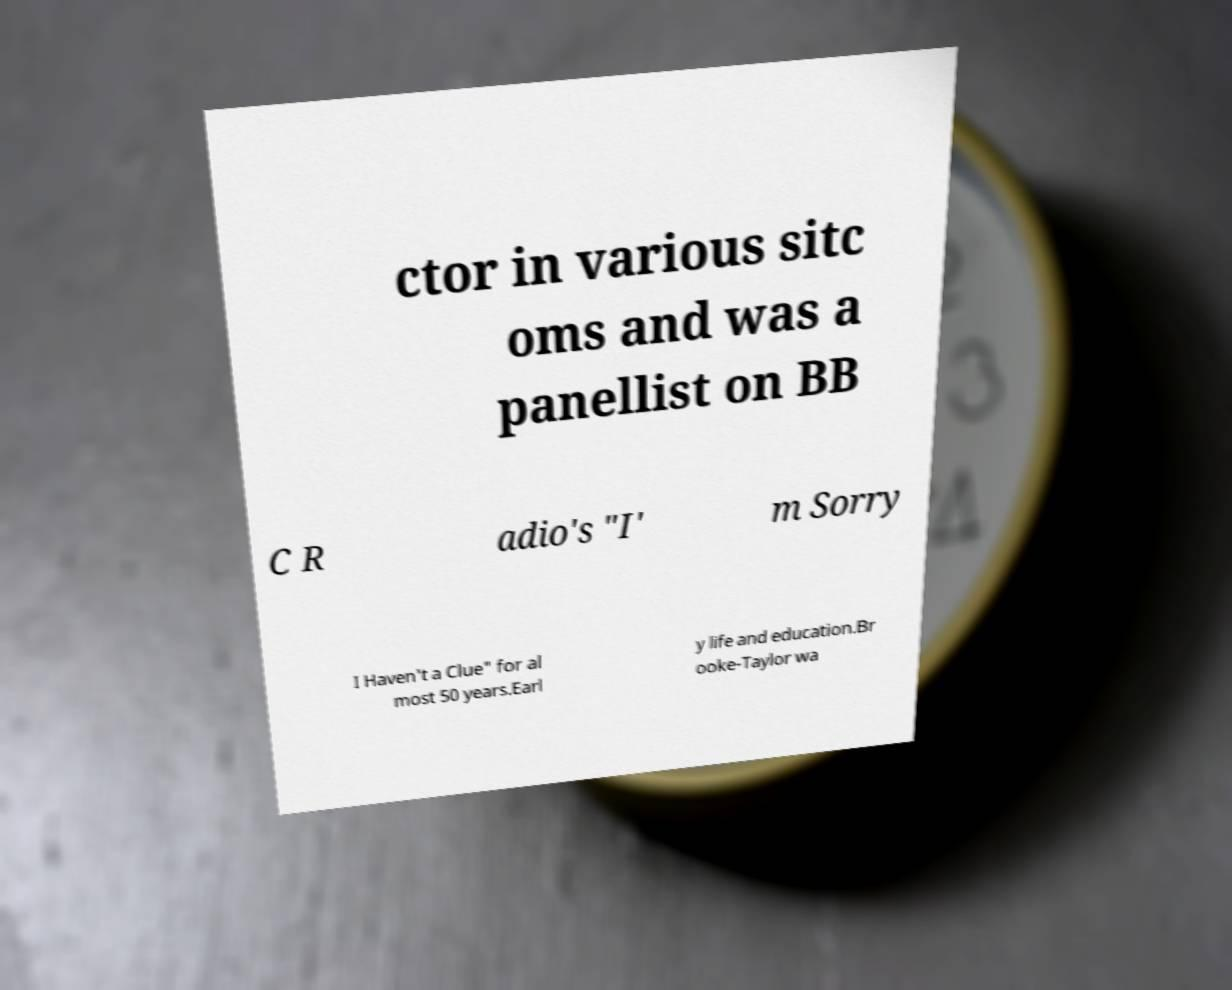I need the written content from this picture converted into text. Can you do that? ctor in various sitc oms and was a panellist on BB C R adio's "I' m Sorry I Haven't a Clue" for al most 50 years.Earl y life and education.Br ooke-Taylor wa 